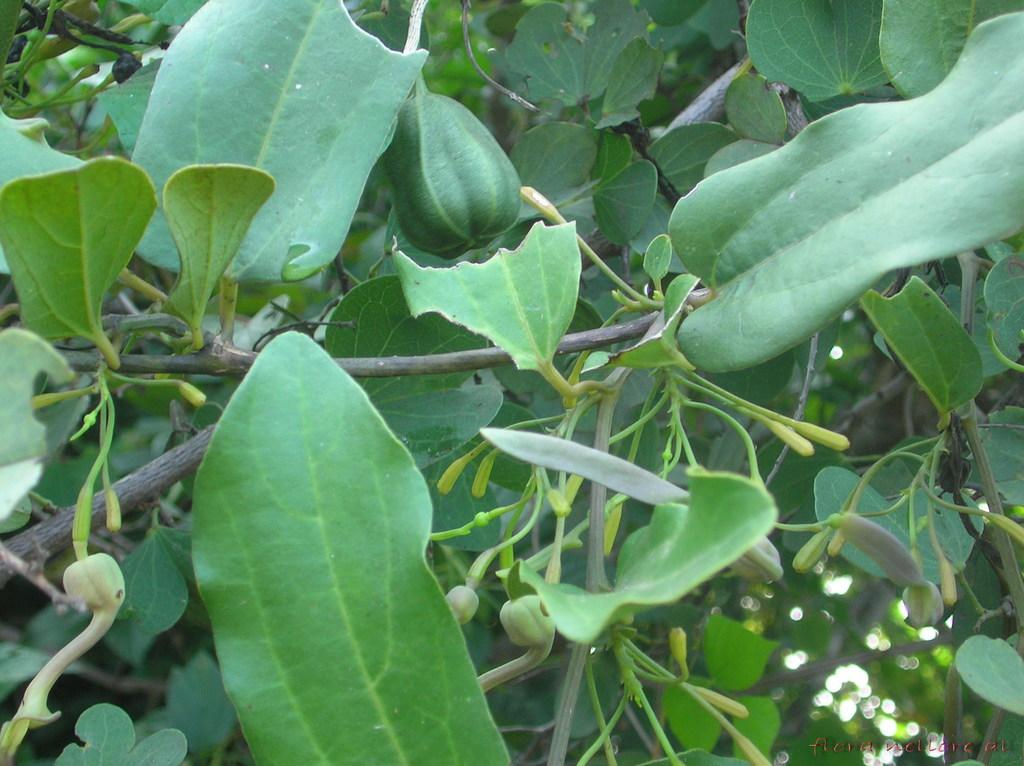What type of plant can be seen in the image? There is a vegetable plant in the image. Can you describe the plant in more detail? Unfortunately, the image only shows the vegetable plant, and no further details are provided. What flavor of nut is present in the image? There are no nuts present in the image; it only features a vegetable plant. 